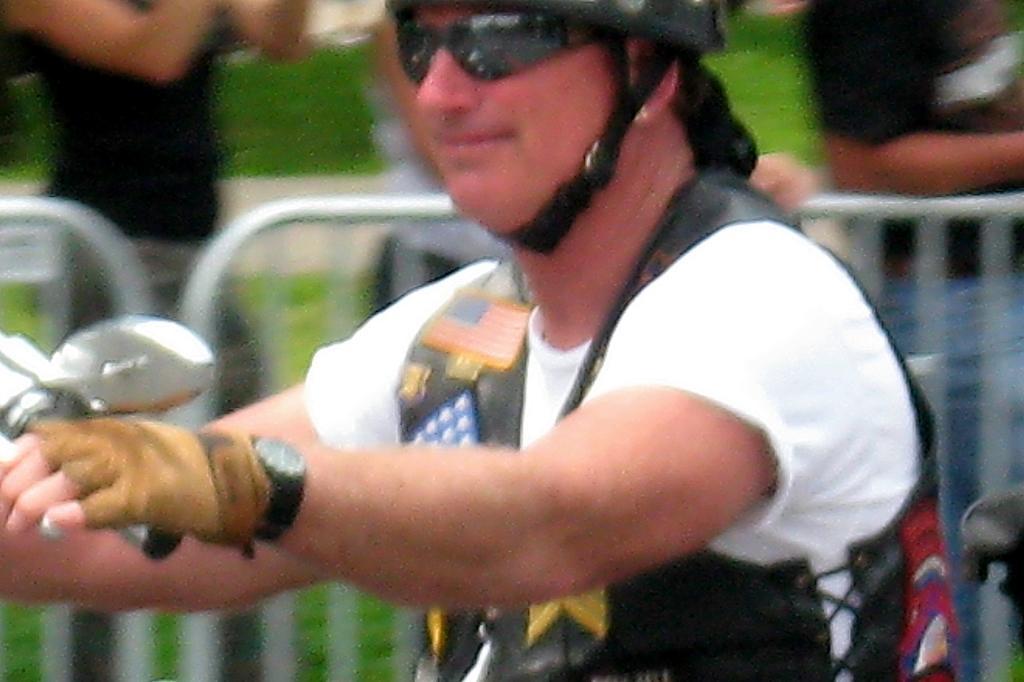Could you give a brief overview of what you see in this image? In this image we can see a person wearing a helmet and riding a bike, there are some people standing and also we can the railings. 